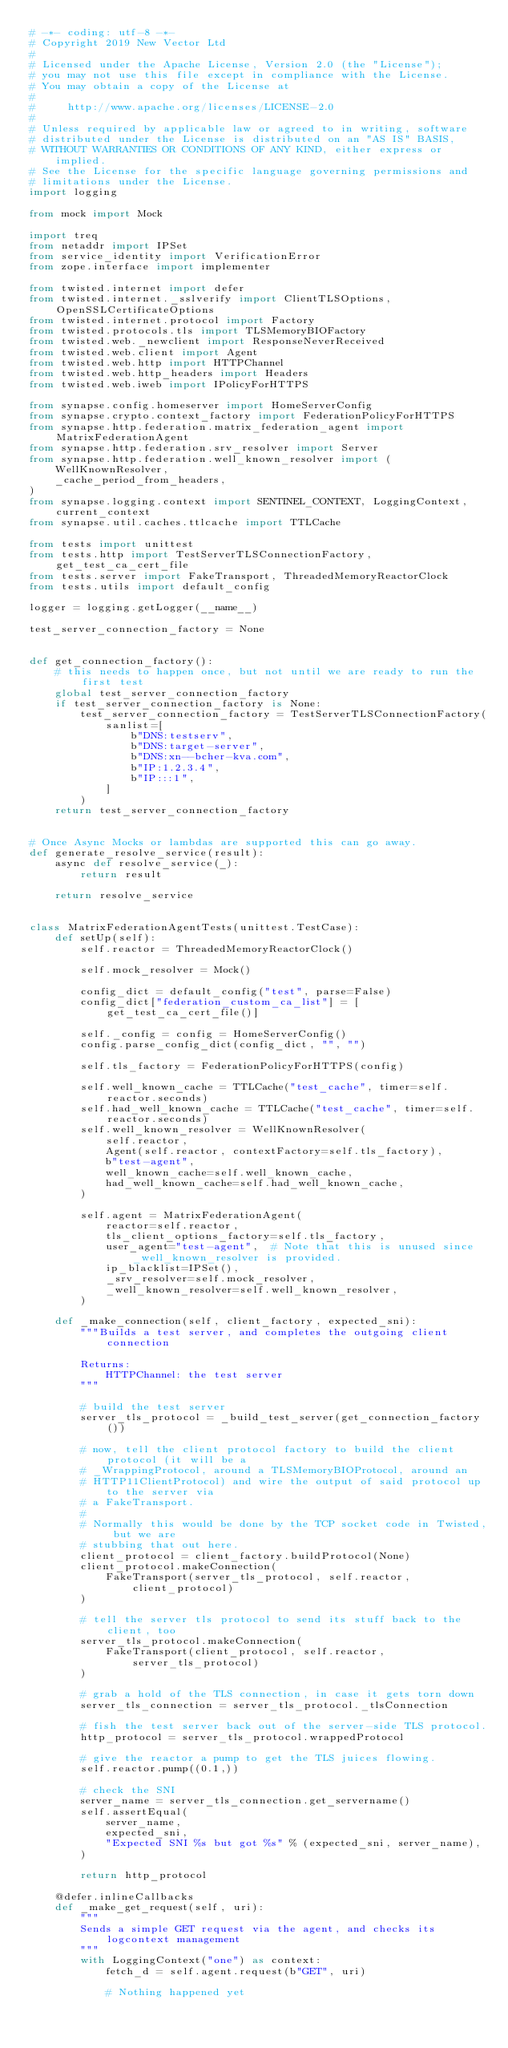Convert code to text. <code><loc_0><loc_0><loc_500><loc_500><_Python_># -*- coding: utf-8 -*-
# Copyright 2019 New Vector Ltd
#
# Licensed under the Apache License, Version 2.0 (the "License");
# you may not use this file except in compliance with the License.
# You may obtain a copy of the License at
#
#     http://www.apache.org/licenses/LICENSE-2.0
#
# Unless required by applicable law or agreed to in writing, software
# distributed under the License is distributed on an "AS IS" BASIS,
# WITHOUT WARRANTIES OR CONDITIONS OF ANY KIND, either express or implied.
# See the License for the specific language governing permissions and
# limitations under the License.
import logging

from mock import Mock

import treq
from netaddr import IPSet
from service_identity import VerificationError
from zope.interface import implementer

from twisted.internet import defer
from twisted.internet._sslverify import ClientTLSOptions, OpenSSLCertificateOptions
from twisted.internet.protocol import Factory
from twisted.protocols.tls import TLSMemoryBIOFactory
from twisted.web._newclient import ResponseNeverReceived
from twisted.web.client import Agent
from twisted.web.http import HTTPChannel
from twisted.web.http_headers import Headers
from twisted.web.iweb import IPolicyForHTTPS

from synapse.config.homeserver import HomeServerConfig
from synapse.crypto.context_factory import FederationPolicyForHTTPS
from synapse.http.federation.matrix_federation_agent import MatrixFederationAgent
from synapse.http.federation.srv_resolver import Server
from synapse.http.federation.well_known_resolver import (
    WellKnownResolver,
    _cache_period_from_headers,
)
from synapse.logging.context import SENTINEL_CONTEXT, LoggingContext, current_context
from synapse.util.caches.ttlcache import TTLCache

from tests import unittest
from tests.http import TestServerTLSConnectionFactory, get_test_ca_cert_file
from tests.server import FakeTransport, ThreadedMemoryReactorClock
from tests.utils import default_config

logger = logging.getLogger(__name__)

test_server_connection_factory = None


def get_connection_factory():
    # this needs to happen once, but not until we are ready to run the first test
    global test_server_connection_factory
    if test_server_connection_factory is None:
        test_server_connection_factory = TestServerTLSConnectionFactory(
            sanlist=[
                b"DNS:testserv",
                b"DNS:target-server",
                b"DNS:xn--bcher-kva.com",
                b"IP:1.2.3.4",
                b"IP:::1",
            ]
        )
    return test_server_connection_factory


# Once Async Mocks or lambdas are supported this can go away.
def generate_resolve_service(result):
    async def resolve_service(_):
        return result

    return resolve_service


class MatrixFederationAgentTests(unittest.TestCase):
    def setUp(self):
        self.reactor = ThreadedMemoryReactorClock()

        self.mock_resolver = Mock()

        config_dict = default_config("test", parse=False)
        config_dict["federation_custom_ca_list"] = [get_test_ca_cert_file()]

        self._config = config = HomeServerConfig()
        config.parse_config_dict(config_dict, "", "")

        self.tls_factory = FederationPolicyForHTTPS(config)

        self.well_known_cache = TTLCache("test_cache", timer=self.reactor.seconds)
        self.had_well_known_cache = TTLCache("test_cache", timer=self.reactor.seconds)
        self.well_known_resolver = WellKnownResolver(
            self.reactor,
            Agent(self.reactor, contextFactory=self.tls_factory),
            b"test-agent",
            well_known_cache=self.well_known_cache,
            had_well_known_cache=self.had_well_known_cache,
        )

        self.agent = MatrixFederationAgent(
            reactor=self.reactor,
            tls_client_options_factory=self.tls_factory,
            user_agent="test-agent",  # Note that this is unused since _well_known_resolver is provided.
            ip_blacklist=IPSet(),
            _srv_resolver=self.mock_resolver,
            _well_known_resolver=self.well_known_resolver,
        )

    def _make_connection(self, client_factory, expected_sni):
        """Builds a test server, and completes the outgoing client connection

        Returns:
            HTTPChannel: the test server
        """

        # build the test server
        server_tls_protocol = _build_test_server(get_connection_factory())

        # now, tell the client protocol factory to build the client protocol (it will be a
        # _WrappingProtocol, around a TLSMemoryBIOProtocol, around an
        # HTTP11ClientProtocol) and wire the output of said protocol up to the server via
        # a FakeTransport.
        #
        # Normally this would be done by the TCP socket code in Twisted, but we are
        # stubbing that out here.
        client_protocol = client_factory.buildProtocol(None)
        client_protocol.makeConnection(
            FakeTransport(server_tls_protocol, self.reactor, client_protocol)
        )

        # tell the server tls protocol to send its stuff back to the client, too
        server_tls_protocol.makeConnection(
            FakeTransport(client_protocol, self.reactor, server_tls_protocol)
        )

        # grab a hold of the TLS connection, in case it gets torn down
        server_tls_connection = server_tls_protocol._tlsConnection

        # fish the test server back out of the server-side TLS protocol.
        http_protocol = server_tls_protocol.wrappedProtocol

        # give the reactor a pump to get the TLS juices flowing.
        self.reactor.pump((0.1,))

        # check the SNI
        server_name = server_tls_connection.get_servername()
        self.assertEqual(
            server_name,
            expected_sni,
            "Expected SNI %s but got %s" % (expected_sni, server_name),
        )

        return http_protocol

    @defer.inlineCallbacks
    def _make_get_request(self, uri):
        """
        Sends a simple GET request via the agent, and checks its logcontext management
        """
        with LoggingContext("one") as context:
            fetch_d = self.agent.request(b"GET", uri)

            # Nothing happened yet</code> 